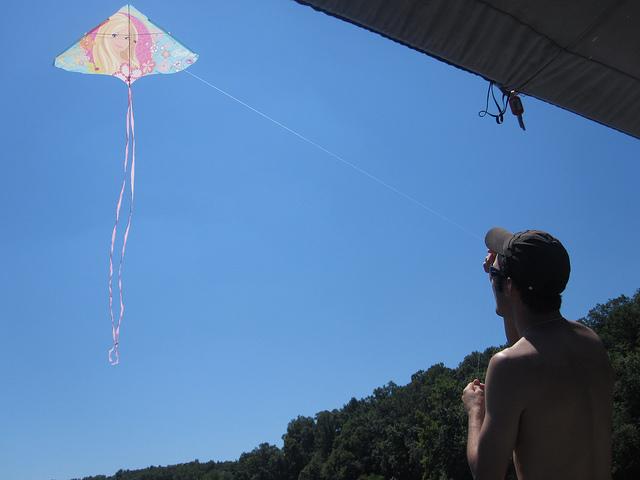Is this an overcast day?
Answer briefly. No. What color is the person's hat?
Give a very brief answer. Black. How many tails does this kite have?
Short answer required. 2. Does the man have a beard?
Give a very brief answer. No. Is it raining?
Short answer required. No. Is the person falling?
Short answer required. No. Would you expect this person to fly this kite on his own?
Write a very short answer. No. Are there clouds visible?
Write a very short answer. No. Is the man in the air?
Be succinct. No. Is it a cloudy day?
Answer briefly. No. What is on the kite?
Short answer required. Barbie. Is the man's hair short?
Write a very short answer. Yes. What color is his hat?
Short answer required. Black. Do you see a sign?
Quick response, please. No. How many kites are in the sky?
Be succinct. 1. Is this photo greyscale?
Write a very short answer. No. What's in the sky?
Be succinct. Kite. Is it light or dark?
Write a very short answer. Light. How high is he jumping?
Be succinct. Not high. What is the man using to hold the kite?
Give a very brief answer. String. 